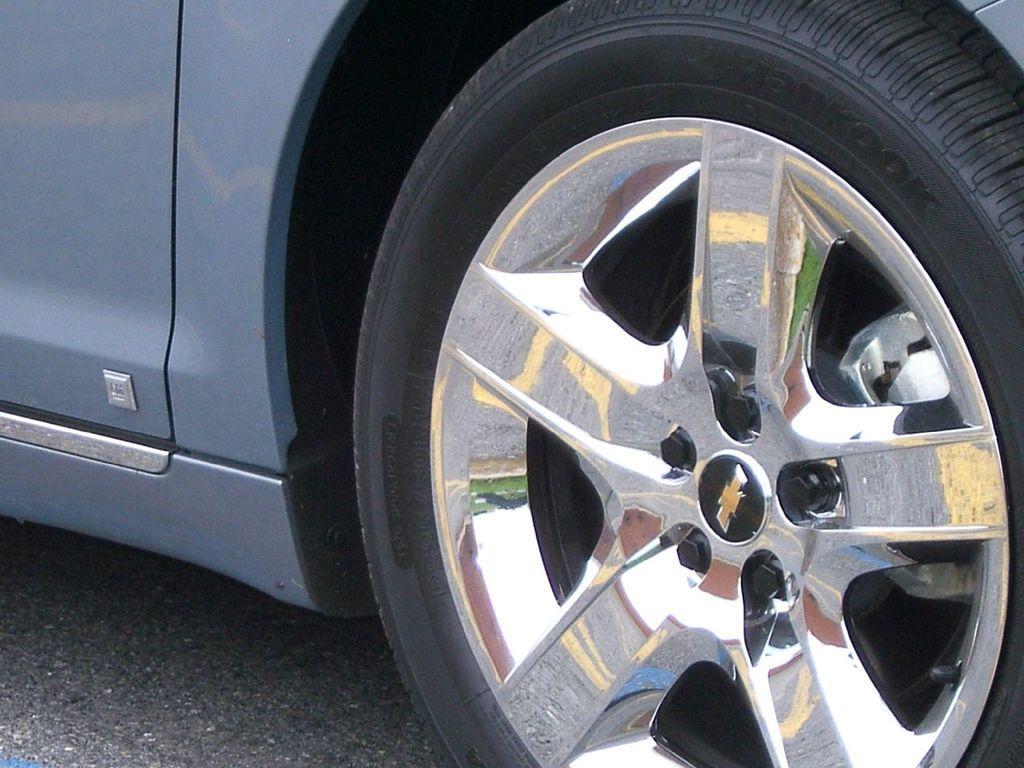Describe this image in one or two sentences. In the picture we can see the car wheel and we can see the wheel alloys to it. The car is in the silver which is on the road. 